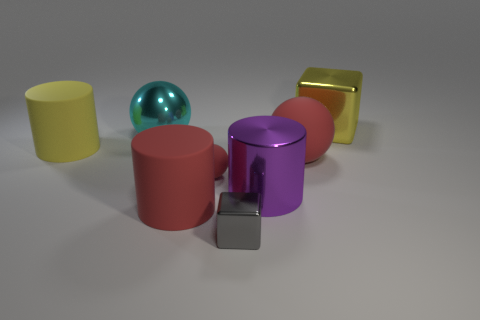What color is the other large matte object that is the same shape as the big yellow rubber object?
Ensure brevity in your answer.  Red. What is the color of the metal cube that is in front of the large yellow thing right of the big yellow cylinder?
Provide a short and direct response. Gray. The tiny gray thing is what shape?
Your answer should be very brief. Cube. There is a shiny thing that is left of the big metal cube and to the right of the gray shiny object; what is its shape?
Give a very brief answer. Cylinder. What is the color of the other cylinder that is made of the same material as the yellow cylinder?
Offer a very short reply. Red. What is the shape of the large metallic object that is in front of the big cylinder left of the red matte thing that is left of the small red matte object?
Your answer should be very brief. Cylinder. The metallic cylinder is what size?
Offer a very short reply. Large. What shape is the big yellow object that is made of the same material as the tiny sphere?
Offer a very short reply. Cylinder. Is the number of rubber cylinders that are in front of the big yellow cylinder less than the number of red balls?
Give a very brief answer. Yes. There is a rubber ball right of the tiny gray metal cube; what color is it?
Keep it short and to the point. Red. 